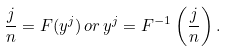<formula> <loc_0><loc_0><loc_500><loc_500>\frac { j } { n } = F ( y ^ { j } ) \, o r \, y ^ { j } = F ^ { - 1 } \left ( \frac { j } { n } \right ) .</formula> 